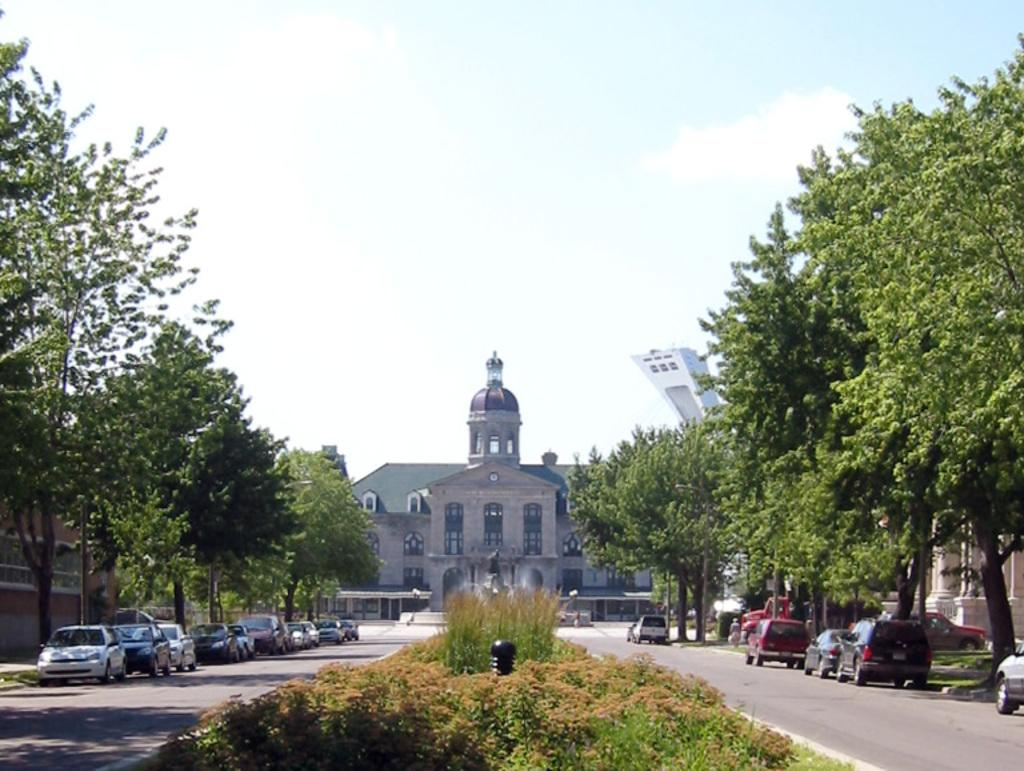What type of living organisms can be seen in the image? Plants and trees are visible in the image. What type of structures can be seen in the image? There are buildings in the image. What type of vehicles can be seen in the image? Cars are visible in the image. What part of the natural environment is visible in the image? The sky is visible in the image. What type of beast can be seen attacking the buildings in the image? There is no beast present in the image, and the buildings are not being attacked. 